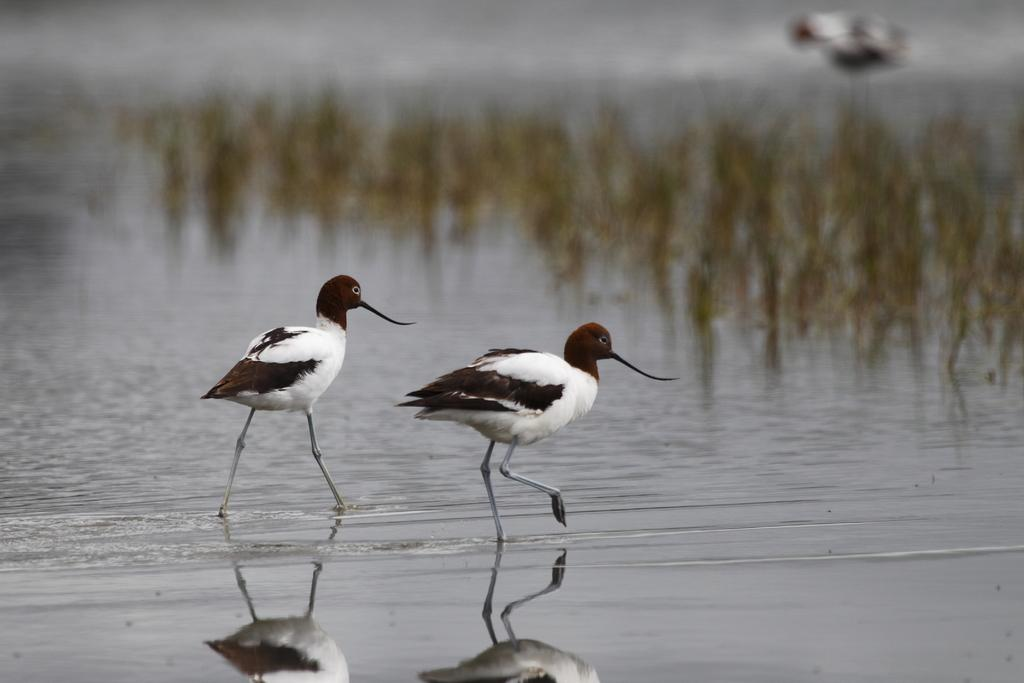How many birds are in the image? There are two birds in the image. Where are the birds located? The birds are in the water. What else can be seen in the image besides the birds? There are plants visible in the image. What type of flower is being held by the giraffe in the image? There is no giraffe or flower present in the image; it features two birds in the water and plants. 